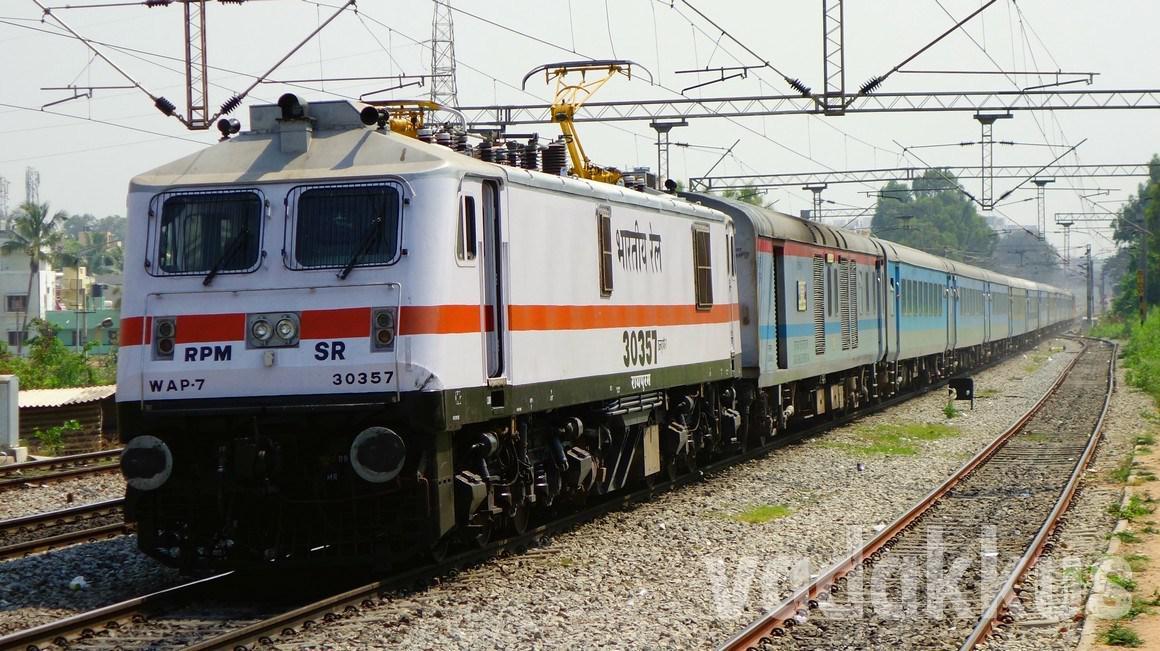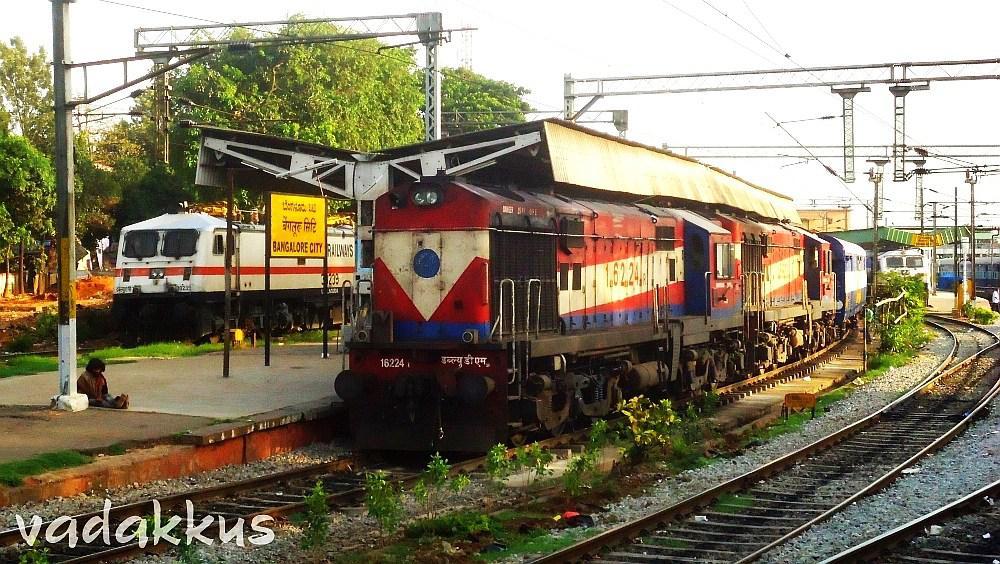The first image is the image on the left, the second image is the image on the right. Given the left and right images, does the statement "The image on the right contains a green and yellow train." hold true? Answer yes or no. No. 